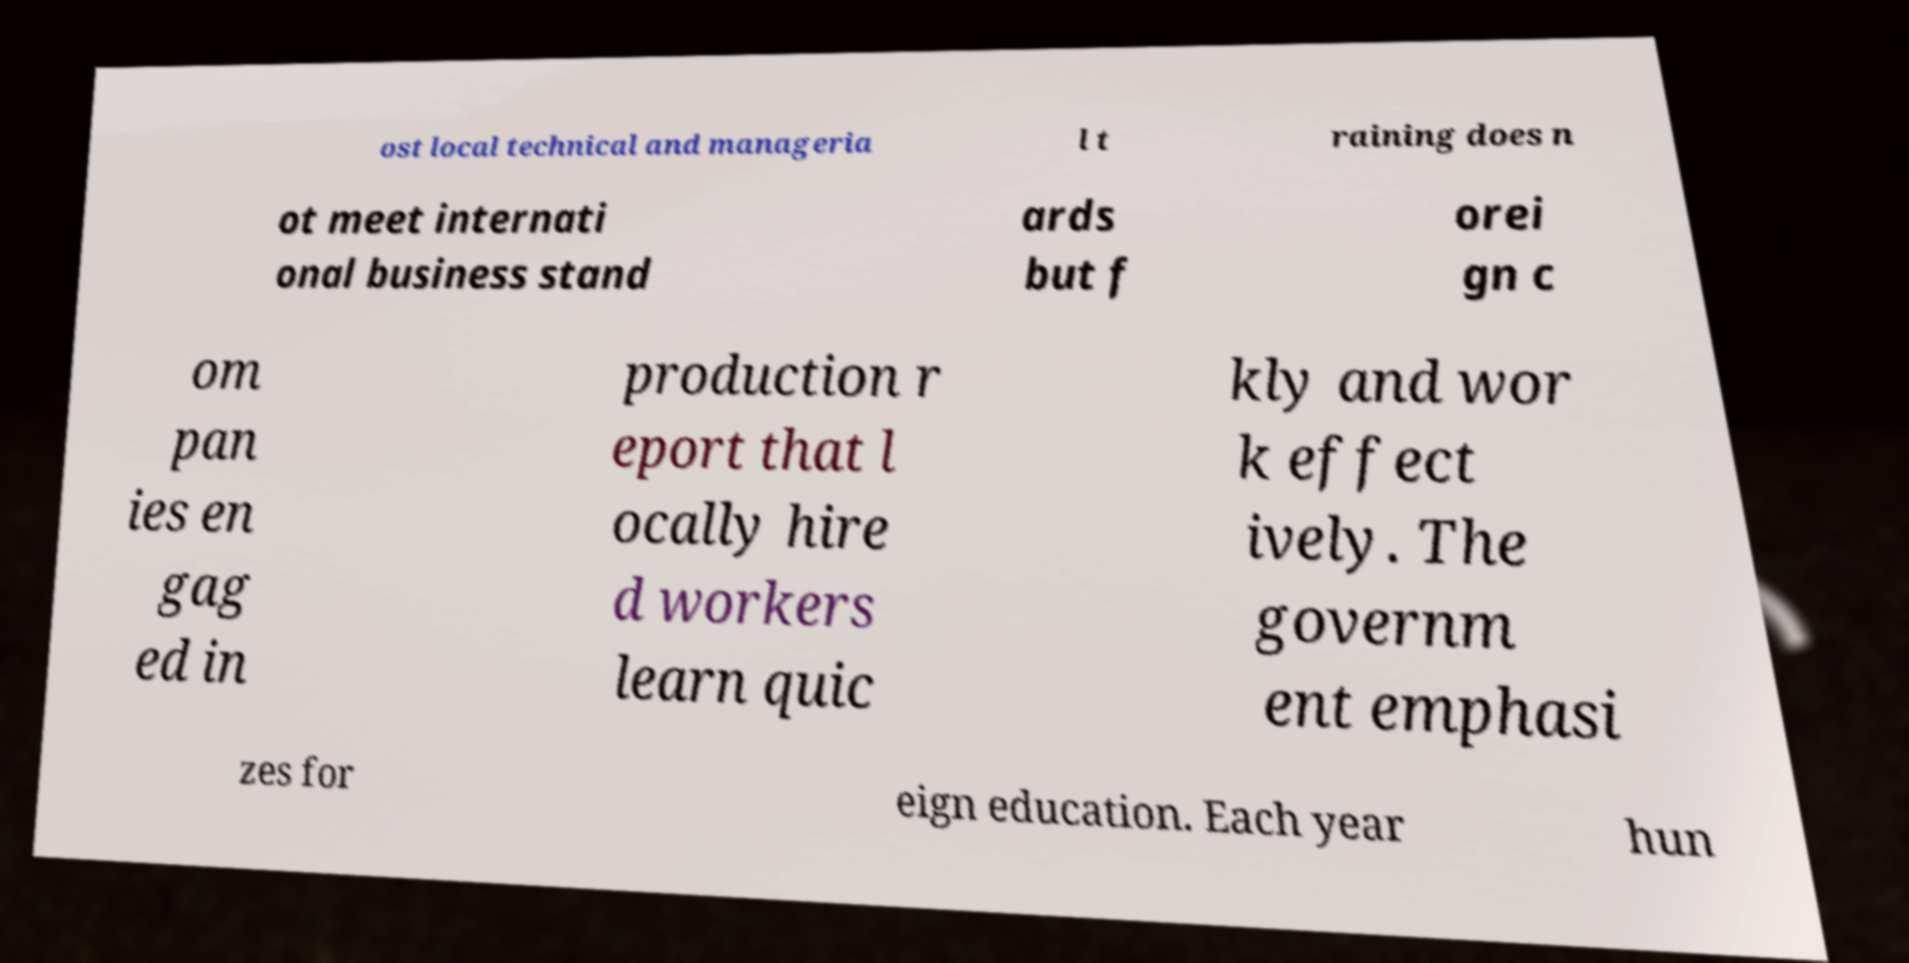For documentation purposes, I need the text within this image transcribed. Could you provide that? ost local technical and manageria l t raining does n ot meet internati onal business stand ards but f orei gn c om pan ies en gag ed in production r eport that l ocally hire d workers learn quic kly and wor k effect ively. The governm ent emphasi zes for eign education. Each year hun 